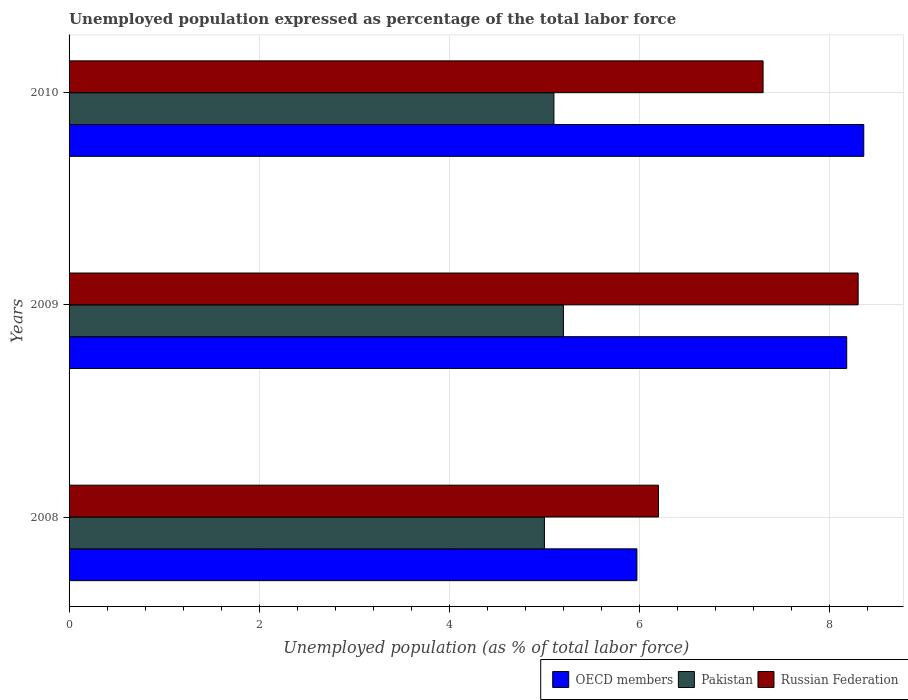Are the number of bars on each tick of the Y-axis equal?
Make the answer very short. Yes. How many bars are there on the 3rd tick from the top?
Your answer should be compact. 3. What is the label of the 3rd group of bars from the top?
Make the answer very short. 2008. In how many cases, is the number of bars for a given year not equal to the number of legend labels?
Offer a very short reply. 0. What is the unemployment in in Pakistan in 2010?
Offer a very short reply. 5.1. Across all years, what is the maximum unemployment in in OECD members?
Your answer should be very brief. 8.36. Across all years, what is the minimum unemployment in in Pakistan?
Ensure brevity in your answer.  5. In which year was the unemployment in in OECD members maximum?
Offer a very short reply. 2010. What is the total unemployment in in OECD members in the graph?
Give a very brief answer. 22.51. What is the difference between the unemployment in in Russian Federation in 2008 and that in 2009?
Offer a very short reply. -2.1. What is the difference between the unemployment in in Russian Federation in 2010 and the unemployment in in OECD members in 2009?
Your answer should be very brief. -0.88. What is the average unemployment in in OECD members per year?
Keep it short and to the point. 7.5. In the year 2008, what is the difference between the unemployment in in OECD members and unemployment in in Pakistan?
Offer a very short reply. 0.97. What is the ratio of the unemployment in in Pakistan in 2008 to that in 2010?
Ensure brevity in your answer.  0.98. Is the unemployment in in Pakistan in 2008 less than that in 2010?
Ensure brevity in your answer.  Yes. Is the difference between the unemployment in in OECD members in 2008 and 2010 greater than the difference between the unemployment in in Pakistan in 2008 and 2010?
Your answer should be very brief. No. What is the difference between the highest and the second highest unemployment in in Pakistan?
Your answer should be compact. 0.1. What is the difference between the highest and the lowest unemployment in in Russian Federation?
Your answer should be very brief. 2.1. In how many years, is the unemployment in in Pakistan greater than the average unemployment in in Pakistan taken over all years?
Your answer should be very brief. 2. What does the 3rd bar from the top in 2009 represents?
Provide a short and direct response. OECD members. What does the 1st bar from the bottom in 2008 represents?
Give a very brief answer. OECD members. How many bars are there?
Keep it short and to the point. 9. Are all the bars in the graph horizontal?
Your answer should be very brief. Yes. How many years are there in the graph?
Keep it short and to the point. 3. What is the difference between two consecutive major ticks on the X-axis?
Provide a short and direct response. 2. Does the graph contain any zero values?
Make the answer very short. No. Does the graph contain grids?
Provide a short and direct response. Yes. How many legend labels are there?
Keep it short and to the point. 3. How are the legend labels stacked?
Offer a terse response. Horizontal. What is the title of the graph?
Give a very brief answer. Unemployed population expressed as percentage of the total labor force. What is the label or title of the X-axis?
Offer a very short reply. Unemployed population (as % of total labor force). What is the Unemployed population (as % of total labor force) of OECD members in 2008?
Your response must be concise. 5.97. What is the Unemployed population (as % of total labor force) of Russian Federation in 2008?
Give a very brief answer. 6.2. What is the Unemployed population (as % of total labor force) of OECD members in 2009?
Ensure brevity in your answer.  8.18. What is the Unemployed population (as % of total labor force) of Pakistan in 2009?
Offer a terse response. 5.2. What is the Unemployed population (as % of total labor force) of Russian Federation in 2009?
Your response must be concise. 8.3. What is the Unemployed population (as % of total labor force) in OECD members in 2010?
Give a very brief answer. 8.36. What is the Unemployed population (as % of total labor force) in Pakistan in 2010?
Give a very brief answer. 5.1. What is the Unemployed population (as % of total labor force) in Russian Federation in 2010?
Provide a succinct answer. 7.3. Across all years, what is the maximum Unemployed population (as % of total labor force) in OECD members?
Give a very brief answer. 8.36. Across all years, what is the maximum Unemployed population (as % of total labor force) in Pakistan?
Your answer should be very brief. 5.2. Across all years, what is the maximum Unemployed population (as % of total labor force) of Russian Federation?
Provide a short and direct response. 8.3. Across all years, what is the minimum Unemployed population (as % of total labor force) in OECD members?
Provide a succinct answer. 5.97. Across all years, what is the minimum Unemployed population (as % of total labor force) of Pakistan?
Your response must be concise. 5. Across all years, what is the minimum Unemployed population (as % of total labor force) in Russian Federation?
Provide a short and direct response. 6.2. What is the total Unemployed population (as % of total labor force) of OECD members in the graph?
Keep it short and to the point. 22.51. What is the total Unemployed population (as % of total labor force) in Russian Federation in the graph?
Your answer should be compact. 21.8. What is the difference between the Unemployed population (as % of total labor force) in OECD members in 2008 and that in 2009?
Provide a short and direct response. -2.21. What is the difference between the Unemployed population (as % of total labor force) in Russian Federation in 2008 and that in 2009?
Offer a very short reply. -2.1. What is the difference between the Unemployed population (as % of total labor force) in OECD members in 2008 and that in 2010?
Provide a short and direct response. -2.39. What is the difference between the Unemployed population (as % of total labor force) in Russian Federation in 2008 and that in 2010?
Your answer should be compact. -1.1. What is the difference between the Unemployed population (as % of total labor force) in OECD members in 2009 and that in 2010?
Offer a very short reply. -0.18. What is the difference between the Unemployed population (as % of total labor force) of Pakistan in 2009 and that in 2010?
Make the answer very short. 0.1. What is the difference between the Unemployed population (as % of total labor force) of OECD members in 2008 and the Unemployed population (as % of total labor force) of Pakistan in 2009?
Keep it short and to the point. 0.77. What is the difference between the Unemployed population (as % of total labor force) in OECD members in 2008 and the Unemployed population (as % of total labor force) in Russian Federation in 2009?
Give a very brief answer. -2.33. What is the difference between the Unemployed population (as % of total labor force) of OECD members in 2008 and the Unemployed population (as % of total labor force) of Pakistan in 2010?
Offer a terse response. 0.87. What is the difference between the Unemployed population (as % of total labor force) of OECD members in 2008 and the Unemployed population (as % of total labor force) of Russian Federation in 2010?
Ensure brevity in your answer.  -1.33. What is the difference between the Unemployed population (as % of total labor force) in OECD members in 2009 and the Unemployed population (as % of total labor force) in Pakistan in 2010?
Ensure brevity in your answer.  3.08. What is the difference between the Unemployed population (as % of total labor force) in OECD members in 2009 and the Unemployed population (as % of total labor force) in Russian Federation in 2010?
Your answer should be compact. 0.88. What is the average Unemployed population (as % of total labor force) of OECD members per year?
Give a very brief answer. 7.5. What is the average Unemployed population (as % of total labor force) in Pakistan per year?
Keep it short and to the point. 5.1. What is the average Unemployed population (as % of total labor force) of Russian Federation per year?
Give a very brief answer. 7.27. In the year 2008, what is the difference between the Unemployed population (as % of total labor force) in OECD members and Unemployed population (as % of total labor force) in Pakistan?
Provide a short and direct response. 0.97. In the year 2008, what is the difference between the Unemployed population (as % of total labor force) of OECD members and Unemployed population (as % of total labor force) of Russian Federation?
Provide a succinct answer. -0.23. In the year 2009, what is the difference between the Unemployed population (as % of total labor force) in OECD members and Unemployed population (as % of total labor force) in Pakistan?
Provide a succinct answer. 2.98. In the year 2009, what is the difference between the Unemployed population (as % of total labor force) in OECD members and Unemployed population (as % of total labor force) in Russian Federation?
Make the answer very short. -0.12. In the year 2010, what is the difference between the Unemployed population (as % of total labor force) of OECD members and Unemployed population (as % of total labor force) of Pakistan?
Make the answer very short. 3.26. In the year 2010, what is the difference between the Unemployed population (as % of total labor force) of OECD members and Unemployed population (as % of total labor force) of Russian Federation?
Your response must be concise. 1.06. What is the ratio of the Unemployed population (as % of total labor force) of OECD members in 2008 to that in 2009?
Your answer should be compact. 0.73. What is the ratio of the Unemployed population (as % of total labor force) of Pakistan in 2008 to that in 2009?
Your answer should be very brief. 0.96. What is the ratio of the Unemployed population (as % of total labor force) in Russian Federation in 2008 to that in 2009?
Keep it short and to the point. 0.75. What is the ratio of the Unemployed population (as % of total labor force) of OECD members in 2008 to that in 2010?
Offer a terse response. 0.71. What is the ratio of the Unemployed population (as % of total labor force) of Pakistan in 2008 to that in 2010?
Ensure brevity in your answer.  0.98. What is the ratio of the Unemployed population (as % of total labor force) in Russian Federation in 2008 to that in 2010?
Offer a terse response. 0.85. What is the ratio of the Unemployed population (as % of total labor force) in OECD members in 2009 to that in 2010?
Your response must be concise. 0.98. What is the ratio of the Unemployed population (as % of total labor force) of Pakistan in 2009 to that in 2010?
Offer a very short reply. 1.02. What is the ratio of the Unemployed population (as % of total labor force) of Russian Federation in 2009 to that in 2010?
Your response must be concise. 1.14. What is the difference between the highest and the second highest Unemployed population (as % of total labor force) of OECD members?
Provide a succinct answer. 0.18. What is the difference between the highest and the second highest Unemployed population (as % of total labor force) in Russian Federation?
Your answer should be very brief. 1. What is the difference between the highest and the lowest Unemployed population (as % of total labor force) of OECD members?
Provide a succinct answer. 2.39. What is the difference between the highest and the lowest Unemployed population (as % of total labor force) of Pakistan?
Offer a terse response. 0.2. What is the difference between the highest and the lowest Unemployed population (as % of total labor force) in Russian Federation?
Offer a terse response. 2.1. 